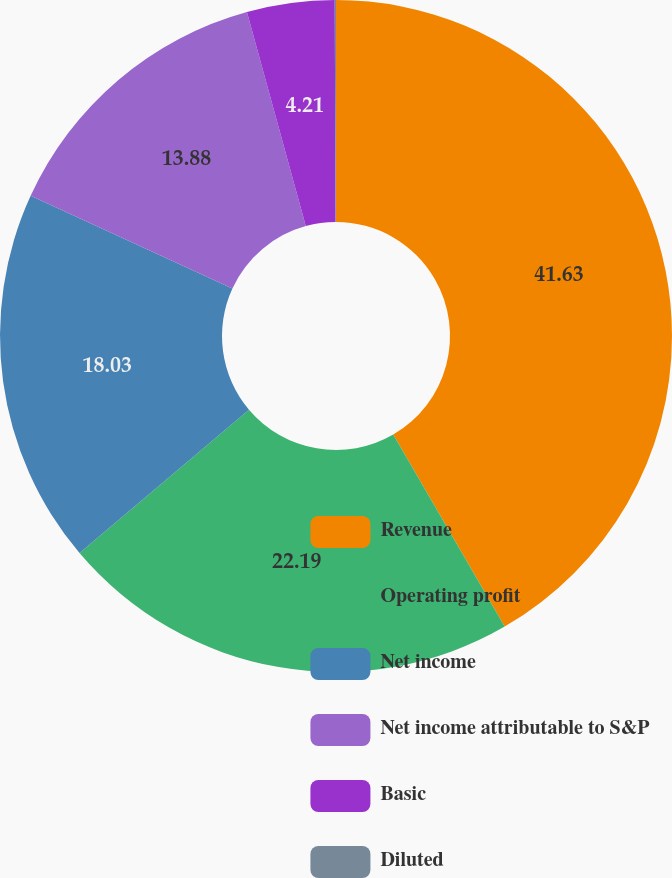<chart> <loc_0><loc_0><loc_500><loc_500><pie_chart><fcel>Revenue<fcel>Operating profit<fcel>Net income<fcel>Net income attributable to S&P<fcel>Basic<fcel>Diluted<nl><fcel>41.63%<fcel>22.19%<fcel>18.03%<fcel>13.88%<fcel>4.21%<fcel>0.06%<nl></chart> 